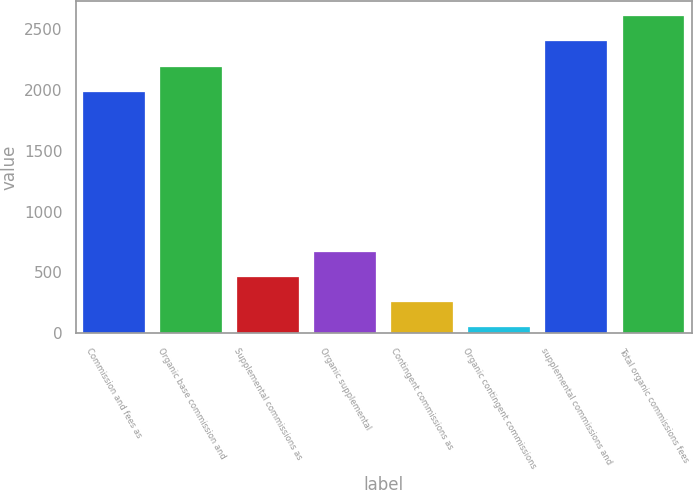Convert chart. <chart><loc_0><loc_0><loc_500><loc_500><bar_chart><fcel>Commission and fees as<fcel>Organic base commission and<fcel>Supplemental commissions as<fcel>Organic supplemental<fcel>Contingent commissions as<fcel>Organic contingent commissions<fcel>supplemental commissions and<fcel>Total organic commissions fees<nl><fcel>1985.6<fcel>2192.11<fcel>464.92<fcel>671.43<fcel>258.41<fcel>51.9<fcel>2398.62<fcel>2605.13<nl></chart> 